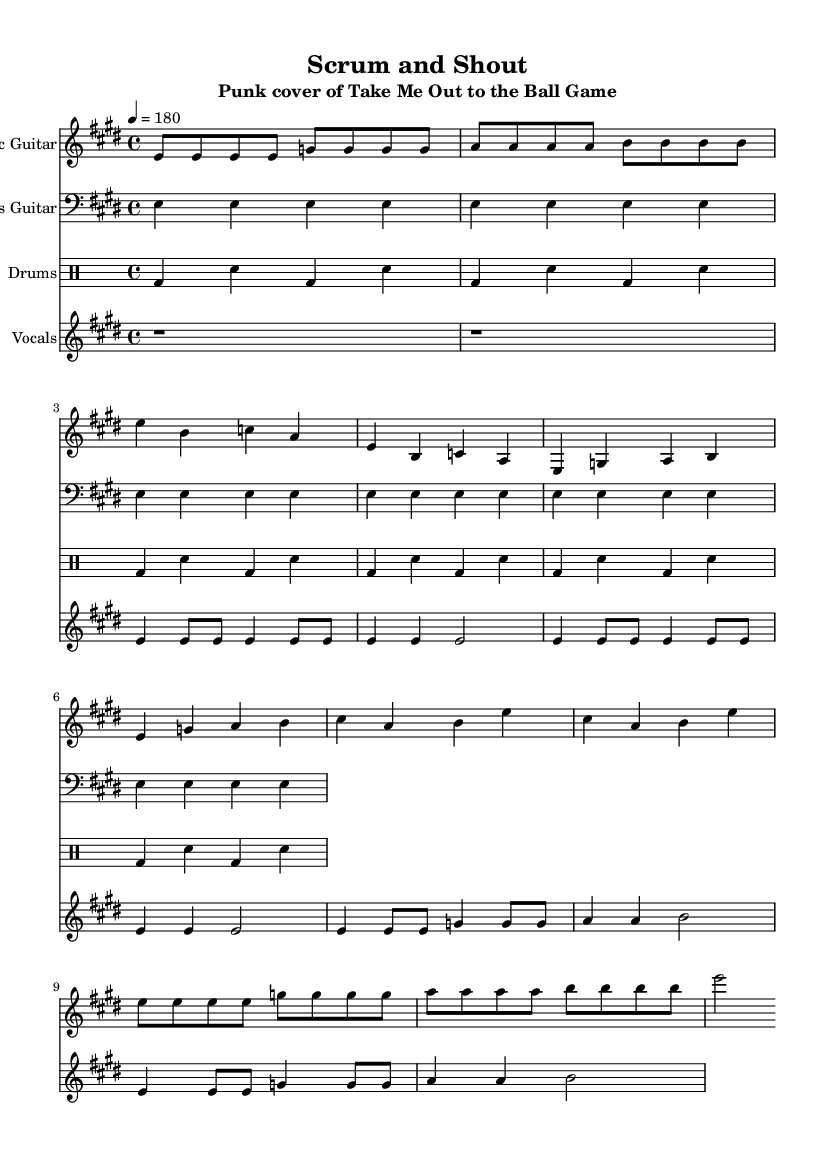What is the key signature of this music? The key signature is E major, which has four sharps: F#, C#, G#, and D#.
Answer: E major What is the time signature of the piece? The time signature is 4/4, indicating there are four beats per measure.
Answer: 4/4 What is the tempo marking of the piece? The tempo marking is 180 beats per minute, indicating a fast pace.
Answer: 180 How many measures are there in the drums part? The drums part consists of six measures, as indicated by the notation without any additional measures following the sixth.
Answer: 6 What notable feature defines the rhythm of the bass line? The bass line features a consistent quarter note rhythm, which provides a steady foundation throughout the piece.
Answer: Quarter notes What is the vocal range indicated for this piece? The vocal range is primarily in the E major scale, centering on E and G for the verse and chorus, indicating a mid-range requirement.
Answer: Mid-range How does the structure of the song reflect punk genre characteristics? The structure is straightforward, comprising verses and a repeated chorus, lending itself to the simplicity typical of punk music.
Answer: Simple structure 